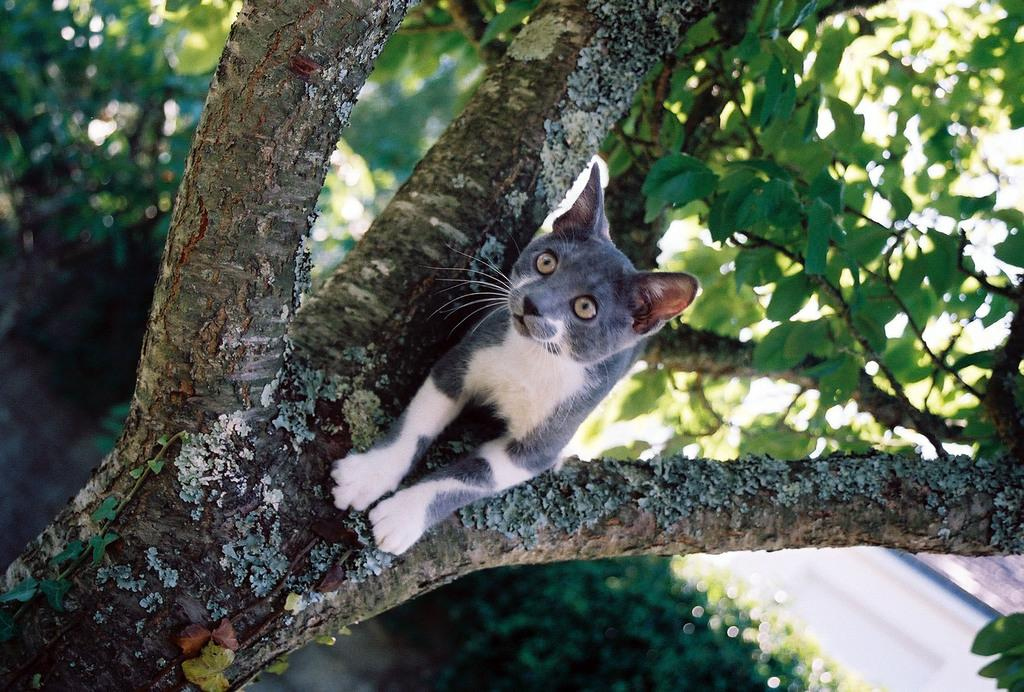What animal is present in the image? There is a cat in the image. Where is the cat located? The cat is on a tree in the image. What type of vegetation can be seen in the image? There are trees and plants visible in the image. Is there any indication of a path or trail in the image? Yes, there is a path in the image. Can you tell me how many goldfish are swimming in the pond in the image? There is no pond or goldfish present in the image; it features a cat on a tree and other vegetation. What type of friends might the cat be playing with in the image? There are no friends or animals interacting with the cat in the image; it is simply perched on a tree branch. 